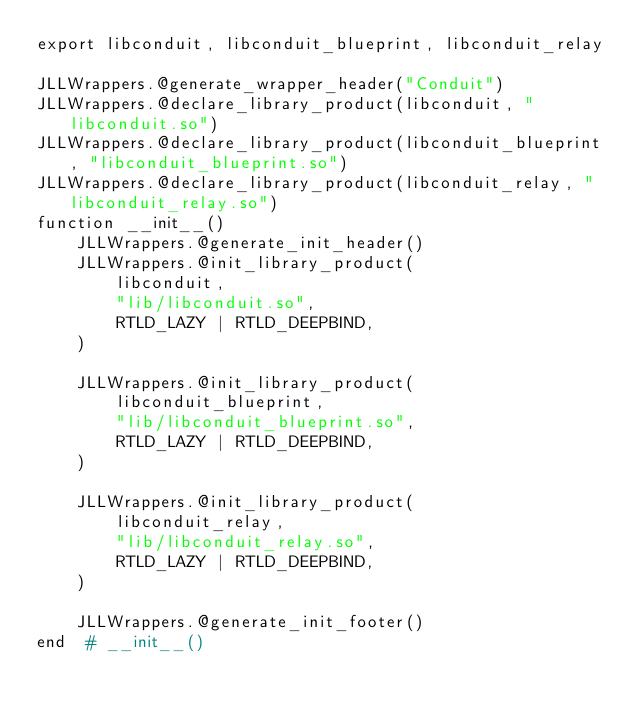Convert code to text. <code><loc_0><loc_0><loc_500><loc_500><_Julia_>export libconduit, libconduit_blueprint, libconduit_relay

JLLWrappers.@generate_wrapper_header("Conduit")
JLLWrappers.@declare_library_product(libconduit, "libconduit.so")
JLLWrappers.@declare_library_product(libconduit_blueprint, "libconduit_blueprint.so")
JLLWrappers.@declare_library_product(libconduit_relay, "libconduit_relay.so")
function __init__()
    JLLWrappers.@generate_init_header()
    JLLWrappers.@init_library_product(
        libconduit,
        "lib/libconduit.so",
        RTLD_LAZY | RTLD_DEEPBIND,
    )

    JLLWrappers.@init_library_product(
        libconduit_blueprint,
        "lib/libconduit_blueprint.so",
        RTLD_LAZY | RTLD_DEEPBIND,
    )

    JLLWrappers.@init_library_product(
        libconduit_relay,
        "lib/libconduit_relay.so",
        RTLD_LAZY | RTLD_DEEPBIND,
    )

    JLLWrappers.@generate_init_footer()
end  # __init__()
</code> 